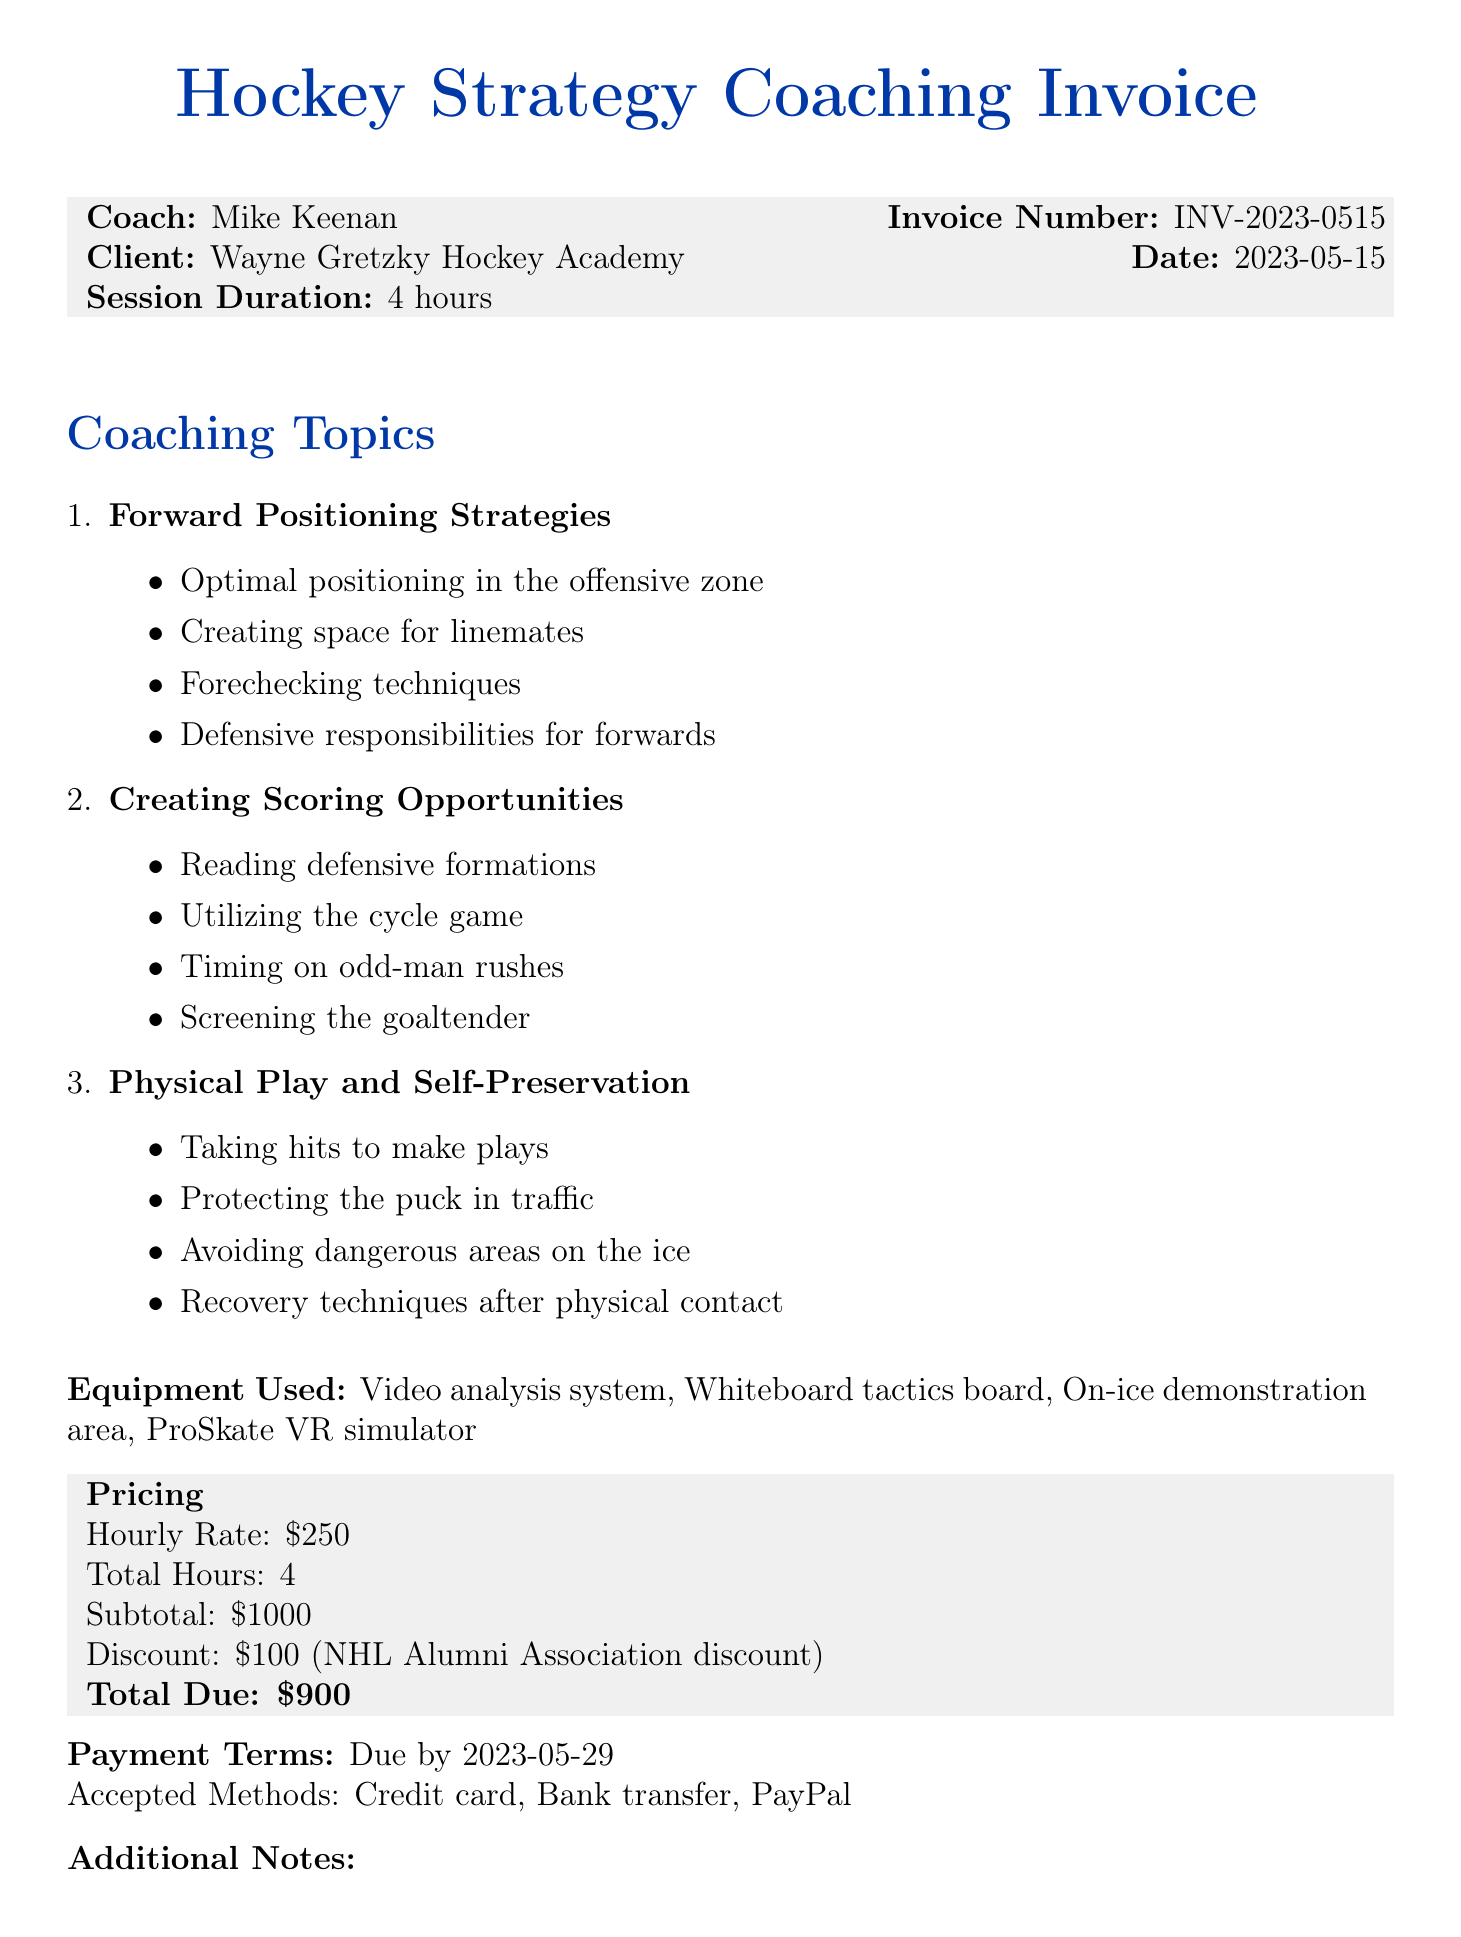What is the coach's name? The document specifies the coach's name as Mike Keenan.
Answer: Mike Keenan What is the total due amount on the invoice? The total due amount is provided in the pricing section and is $900 after the discount.
Answer: $900 What topics were covered in the coaching session? The document lists coaching topics under a specific section, including Forward Positioning Strategies, Creating Scoring Opportunities, and Physical Play and Self-Preservation.
Answer: Forward Positioning Strategies, Creating Scoring Opportunities, Physical Play and Self-Preservation How many hours did the coaching session last? The session duration is mentioned in the invoice details as 4 hours.
Answer: 4 hours What discount was applied to the total? The document notes an NHL Alumni Association discount of $100 applied to the subtotal.
Answer: $100 What is the payment due date? The payment terms section indicates that payment is due by May 29, 2023.
Answer: 2023-05-29 Which equipment was used during the session? The equipment used is listed under a specific section and includes video analysis system and ProSkate VR simulator.
Answer: Video analysis system, Whiteboard tactics board, On-ice demonstration area, ProSkate VR simulator What was included in the additional notes? The additional notes section contains a summary of what was included in the session, such as personalized video breakdown.
Answer: Personalized video breakdown of client's former NHL games 